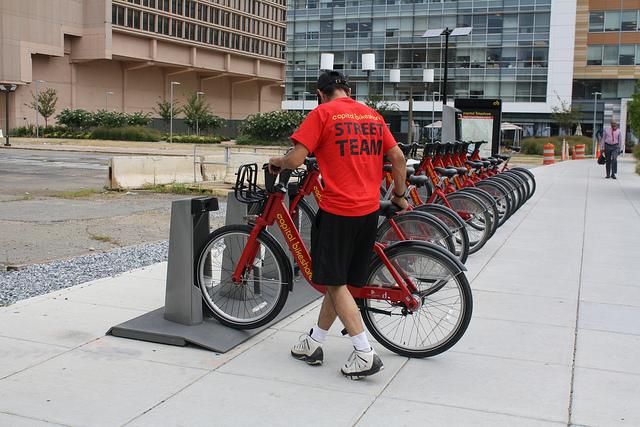Is he on a team?
Write a very short answer. Yes. Is the man by the water?
Short answer required. No. How far up his heel does the black section on his shoes rise?
Write a very short answer. Halfway. What is that red metal thing in the ground?
Write a very short answer. Bike. What is the man doing?
Concise answer only. Biking. Is the cyclist old?
Be succinct. No. Are all the bikes the same color?
Answer briefly. Yes. 